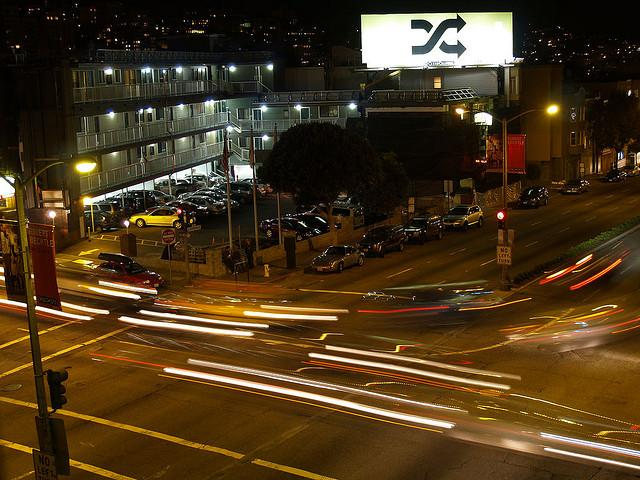What creates the colorful patterns on the ground? Please explain your reasoning. traffic. There is a lot of traffic from moving cars. 